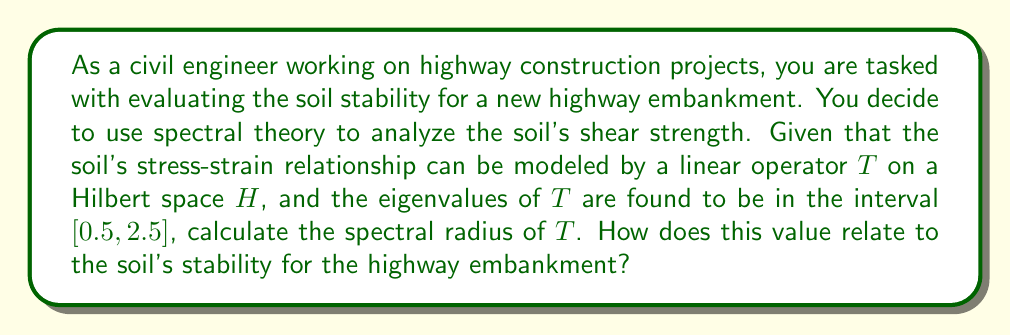Solve this math problem. To solve this problem, we need to understand the concept of spectral radius and its significance in soil stability analysis:

1. Spectral radius definition:
   The spectral radius $\rho(T)$ of a linear operator $T$ is defined as:
   $$\rho(T) = \sup\{|\lambda| : \lambda \in \sigma(T)\}$$
   where $\sigma(T)$ is the spectrum of $T$, which includes all eigenvalues.

2. Given information:
   - The eigenvalues of $T$ are in the interval $[0.5, 2.5]$
   - This means $0.5 \leq \lambda \leq 2.5$ for all eigenvalues $\lambda$

3. Calculating the spectral radius:
   Since the spectral radius is the supremum of the absolute values of eigenvalues, we need to find the largest absolute value in the given interval.
   $$\rho(T) = \max\{|0.5|, |2.5|\} = 2.5$$

4. Interpretation for soil stability:
   In soil mechanics, the spectral radius can be related to the soil's shear strength and its ability to resist deformation under stress. A larger spectral radius generally indicates higher soil stiffness and better stability.

   - If $\rho(T) < 1$, the soil may be prone to large deformations and potential instability.
   - If $\rho(T) = 1$, the soil is at a critical state.
   - If $\rho(T) > 1$, as in this case, the soil is likely to have good stability characteristics.

5. Relevance to highway embankment:
   With a spectral radius of 2.5, which is significantly greater than 1, the soil is expected to have good stability properties for the highway embankment. This suggests that the soil has sufficient shear strength to support the embankment load and resist excessive deformation.

   However, it's important to note that while this spectral analysis provides valuable insights, other factors such as soil type, moisture content, and loading conditions should also be considered for a comprehensive stability assessment.
Answer: The spectral radius of the linear operator $T$ is $\rho(T) = 2.5$. This value indicates good soil stability for the highway embankment, as it is significantly greater than 1, suggesting sufficient shear strength and resistance to deformation under expected loads. 